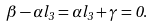Convert formula to latex. <formula><loc_0><loc_0><loc_500><loc_500>\beta - \alpha l _ { 3 } = \alpha l _ { 3 } + \gamma = 0 .</formula> 